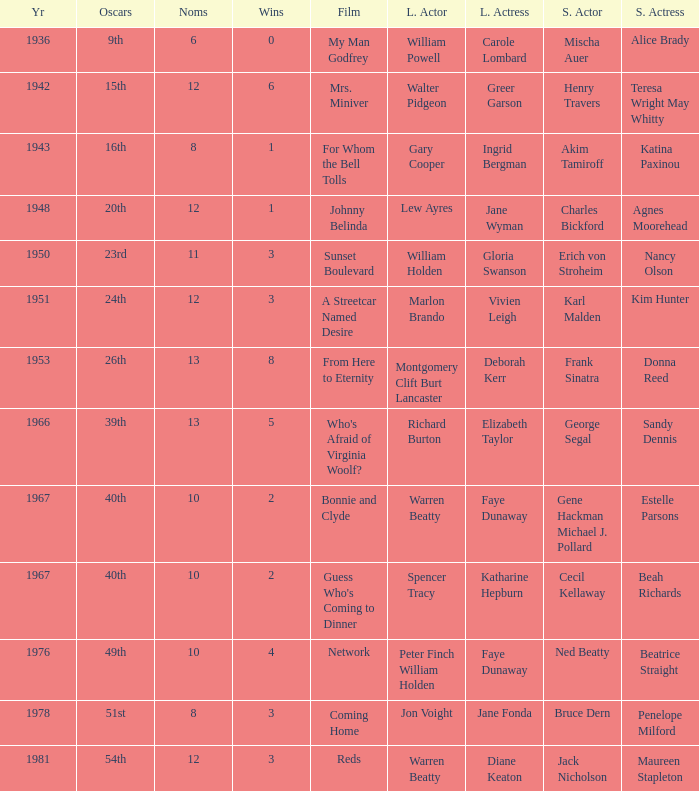Who was the supporting actress in a film with Diane Keaton as the leading actress? Maureen Stapleton. 